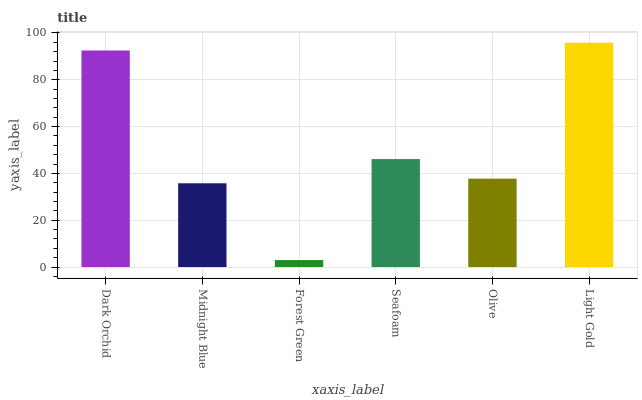Is Forest Green the minimum?
Answer yes or no. Yes. Is Light Gold the maximum?
Answer yes or no. Yes. Is Midnight Blue the minimum?
Answer yes or no. No. Is Midnight Blue the maximum?
Answer yes or no. No. Is Dark Orchid greater than Midnight Blue?
Answer yes or no. Yes. Is Midnight Blue less than Dark Orchid?
Answer yes or no. Yes. Is Midnight Blue greater than Dark Orchid?
Answer yes or no. No. Is Dark Orchid less than Midnight Blue?
Answer yes or no. No. Is Seafoam the high median?
Answer yes or no. Yes. Is Olive the low median?
Answer yes or no. Yes. Is Dark Orchid the high median?
Answer yes or no. No. Is Midnight Blue the low median?
Answer yes or no. No. 